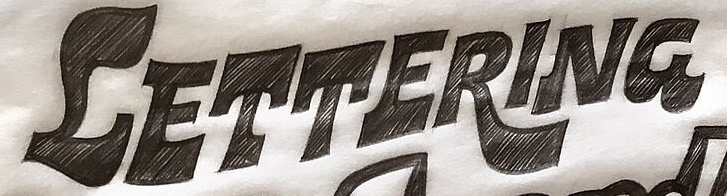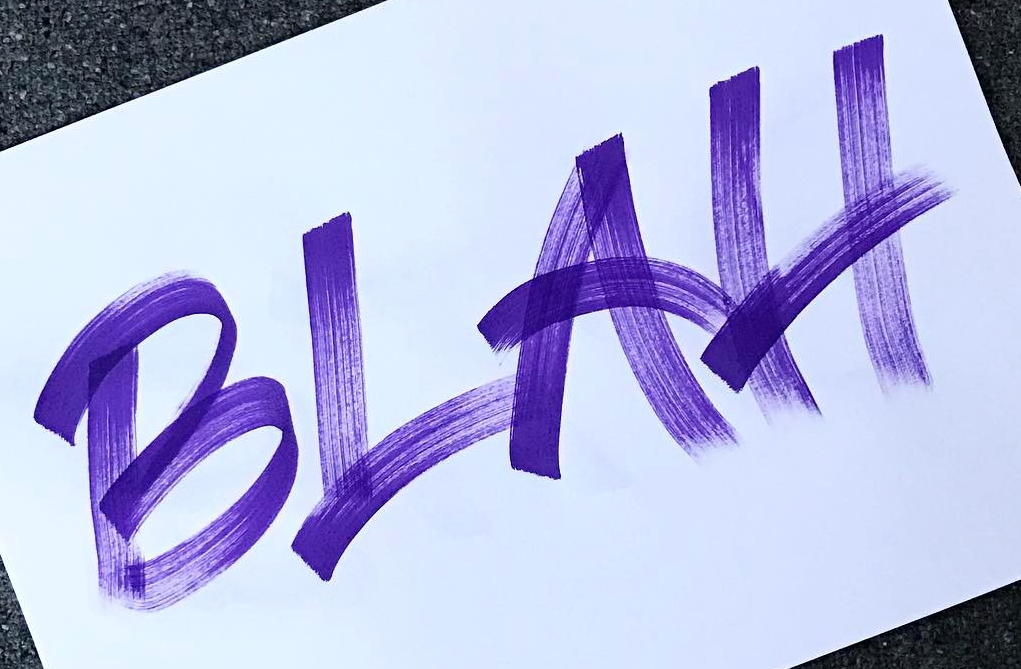Read the text from these images in sequence, separated by a semicolon. CETTERING; BLAH 